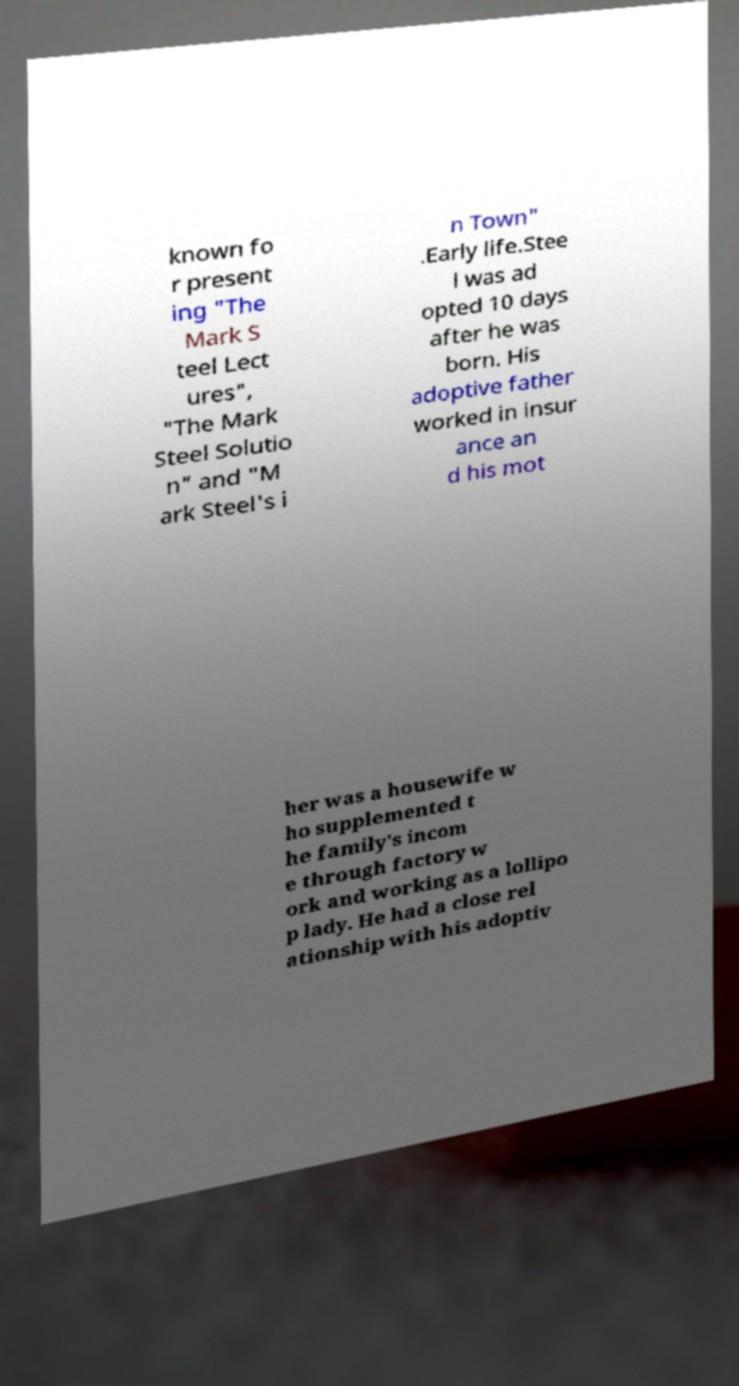For documentation purposes, I need the text within this image transcribed. Could you provide that? known fo r present ing "The Mark S teel Lect ures", "The Mark Steel Solutio n" and "M ark Steel's i n Town" .Early life.Stee l was ad opted 10 days after he was born. His adoptive father worked in insur ance an d his mot her was a housewife w ho supplemented t he family's incom e through factory w ork and working as a lollipo p lady. He had a close rel ationship with his adoptiv 